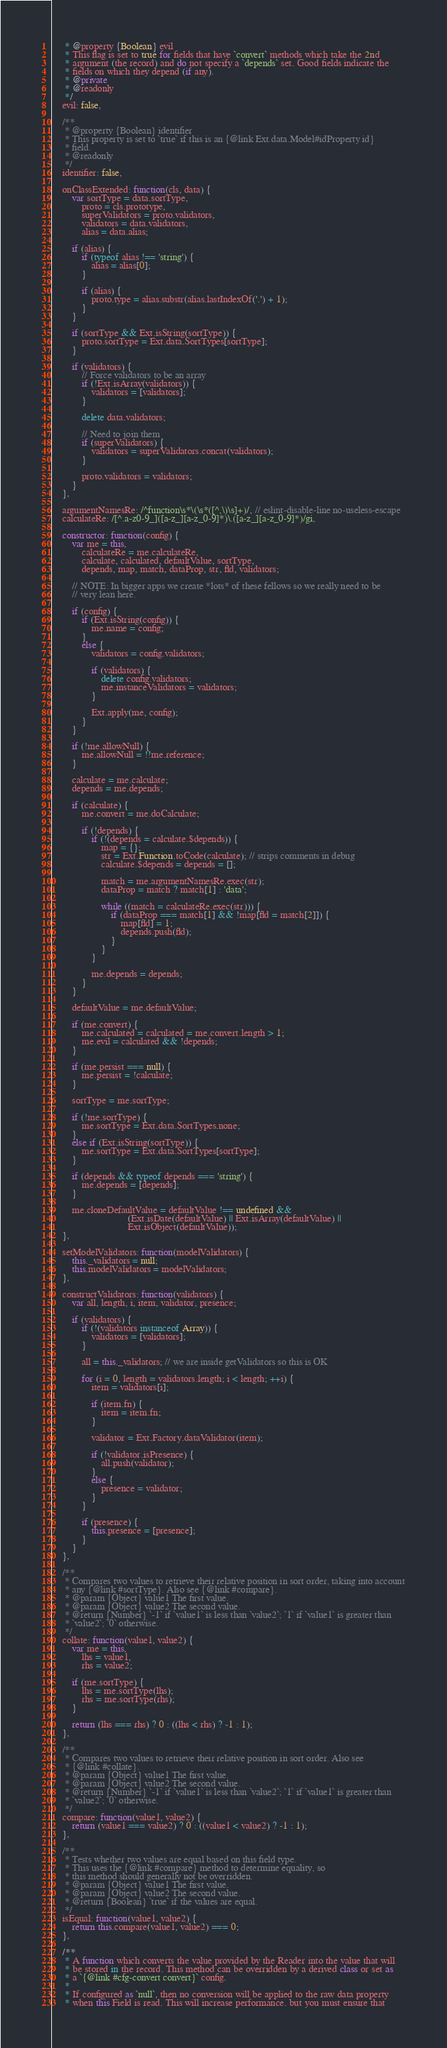<code> <loc_0><loc_0><loc_500><loc_500><_JavaScript_>     * @property {Boolean} evil
     * This flag is set to true for fields that have `convert` methods which take the 2nd
     * argument (the record) and do not specify a `depends` set. Good fields indicate the
     * fields on which they depend (if any).
     * @private
     * @readonly
     */
    evil: false,

    /**
     * @property {Boolean} identifier
     * This property is set to `true` if this is an {@link Ext.data.Model#idProperty id}
     * field.
     * @readonly
     */
    identifier: false,

    onClassExtended: function(cls, data) {
        var sortType = data.sortType,
            proto = cls.prototype,
            superValidators = proto.validators,
            validators = data.validators,
            alias = data.alias;

        if (alias) {
            if (typeof alias !== 'string') {
                alias = alias[0];
            }

            if (alias) {
                proto.type = alias.substr(alias.lastIndexOf('.') + 1);
            }
        }

        if (sortType && Ext.isString(sortType)) {
            proto.sortType = Ext.data.SortTypes[sortType];
        }

        if (validators) {
            // Force validators to be an array
            if (!Ext.isArray(validators)) {
                validators = [validators];
            }

            delete data.validators;

            // Need to join them
            if (superValidators) {
                validators = superValidators.concat(validators);
            }

            proto.validators = validators;
        }
    },

    argumentNamesRe: /^function\s*\(\s*([^,\)\s]+)/, // eslint-disable-line no-useless-escape
    calculateRe: /[^.a-z0-9_]([a-z_][a-z_0-9]*)\.([a-z_][a-z_0-9]*)/gi,

    constructor: function(config) {
        var me = this,
            calculateRe = me.calculateRe,
            calculate, calculated, defaultValue, sortType,
            depends, map, match, dataProp, str, fld, validators;

        // NOTE: In bigger apps we create *lots* of these fellows so we really need to be
        // very lean here.

        if (config) {
            if (Ext.isString(config)) {
                me.name = config;
            }
            else {
                validators = config.validators;

                if (validators) {
                    delete config.validators;
                    me.instanceValidators = validators;
                }

                Ext.apply(me, config);
            }
        }

        if (!me.allowNull) {
            me.allowNull = !!me.reference;
        }

        calculate = me.calculate;
        depends = me.depends;

        if (calculate) {
            me.convert = me.doCalculate;

            if (!depends) {
                if (!(depends = calculate.$depends)) {
                    map = {};
                    str = Ext.Function.toCode(calculate); // strips comments in debug
                    calculate.$depends = depends = [];

                    match = me.argumentNamesRe.exec(str);
                    dataProp = match ? match[1] : 'data';

                    while ((match = calculateRe.exec(str))) {
                        if (dataProp === match[1] && !map[fld = match[2]]) {
                            map[fld] = 1;
                            depends.push(fld);
                        }
                    }
                }

                me.depends = depends;
            }
        }

        defaultValue = me.defaultValue;

        if (me.convert) {
            me.calculated = calculated = me.convert.length > 1;
            me.evil = calculated && !depends;
        }

        if (me.persist === null) {
            me.persist = !calculate;
        }

        sortType = me.sortType;

        if (!me.sortType) {
            me.sortType = Ext.data.SortTypes.none;
        }
        else if (Ext.isString(sortType)) {
            me.sortType = Ext.data.SortTypes[sortType];
        }

        if (depends && typeof depends === 'string') {
            me.depends = [depends];
        }

        me.cloneDefaultValue = defaultValue !== undefined &&
                               (Ext.isDate(defaultValue) || Ext.isArray(defaultValue) ||
                               Ext.isObject(defaultValue));
    },

    setModelValidators: function(modelValidators) {
        this._validators = null;
        this.modelValidators = modelValidators;
    },

    constructValidators: function(validators) {
        var all, length, i, item, validator, presence;

        if (validators) {
            if (!(validators instanceof Array)) {
                validators = [validators];
            }

            all = this._validators; // we are inside getValidators so this is OK

            for (i = 0, length = validators.length; i < length; ++i) {
                item = validators[i];

                if (item.fn) {
                    item = item.fn;
                }

                validator = Ext.Factory.dataValidator(item);

                if (!validator.isPresence) {
                    all.push(validator);
                }
                else {
                    presence = validator;
                }
            }

            if (presence) {
                this.presence = [presence];
            }
        }
    },

    /**
     * Compares two values to retrieve their relative position in sort order, taking into account
     * any {@link #sortType}. Also see {@link #compare}.
     * @param {Object} value1 The first value.
     * @param {Object} value2 The second value.
     * @return {Number} `-1` if `value1` is less than `value2`; `1` if `value1` is greater than
     * `value2`; `0` otherwise.
     */
    collate: function(value1, value2) {
        var me = this,
            lhs = value1,
            rhs = value2;

        if (me.sortType) {
            lhs = me.sortType(lhs);
            rhs = me.sortType(rhs);
        }

        return (lhs === rhs) ? 0 : ((lhs < rhs) ? -1 : 1);
    },

    /**
     * Compares two values to retrieve their relative position in sort order. Also see
     * {@link #collate}.
     * @param {Object} value1 The first value.
     * @param {Object} value2 The second value.
     * @return {Number} `-1` if `value1` is less than `value2`; `1` if `value1` is greater than
     * `value2`; `0` otherwise.
     */
    compare: function(value1, value2) {
        return (value1 === value2) ? 0 : ((value1 < value2) ? -1 : 1);
    },

    /**
     * Tests whether two values are equal based on this field type.
     * This uses the {@link #compare} method to determine equality, so
     * this method should generally not be overridden.
     * @param {Object} value1 The first value.
     * @param {Object} value2 The second value.
     * @return {Boolean} `true` if the values are equal.
     */
    isEqual: function(value1, value2) {
        return this.compare(value1, value2) === 0;
    },

    /**
     * A function which converts the value provided by the Reader into the value that will
     * be stored in the record. This method can be overridden by a derived class or set as
     * a `{@link #cfg-convert convert}` config.
     *
     * If configured as `null`, then no conversion will be applied to the raw data property
     * when this Field is read. This will increase performance. but you must ensure that</code> 